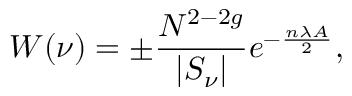Convert formula to latex. <formula><loc_0><loc_0><loc_500><loc_500>W ( \nu ) = \pm \frac { N ^ { 2 - 2 g } } { | S _ { \nu } | } e ^ { - \frac { n \lambda A } { 2 } } ,</formula> 